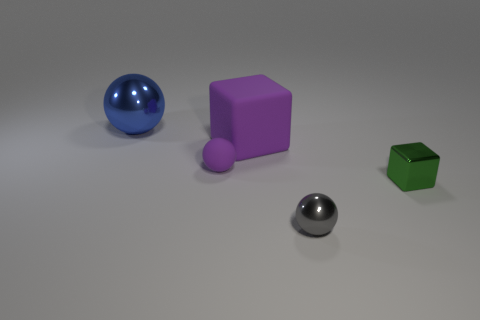Add 2 big purple cylinders. How many objects exist? 7 Subtract all shiny balls. How many balls are left? 1 Subtract all green cubes. How many cubes are left? 1 Subtract all balls. How many objects are left? 2 Add 2 big blue things. How many big blue things exist? 3 Subtract 0 brown cubes. How many objects are left? 5 Subtract 2 balls. How many balls are left? 1 Subtract all blue spheres. Subtract all red blocks. How many spheres are left? 2 Subtract all brown cylinders. How many green cubes are left? 1 Subtract all small shiny cubes. Subtract all large green shiny balls. How many objects are left? 4 